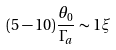Convert formula to latex. <formula><loc_0><loc_0><loc_500><loc_500>( 5 - 1 0 ) \frac { \theta _ { 0 } } { \Gamma _ { a } } \sim 1 \xi</formula> 